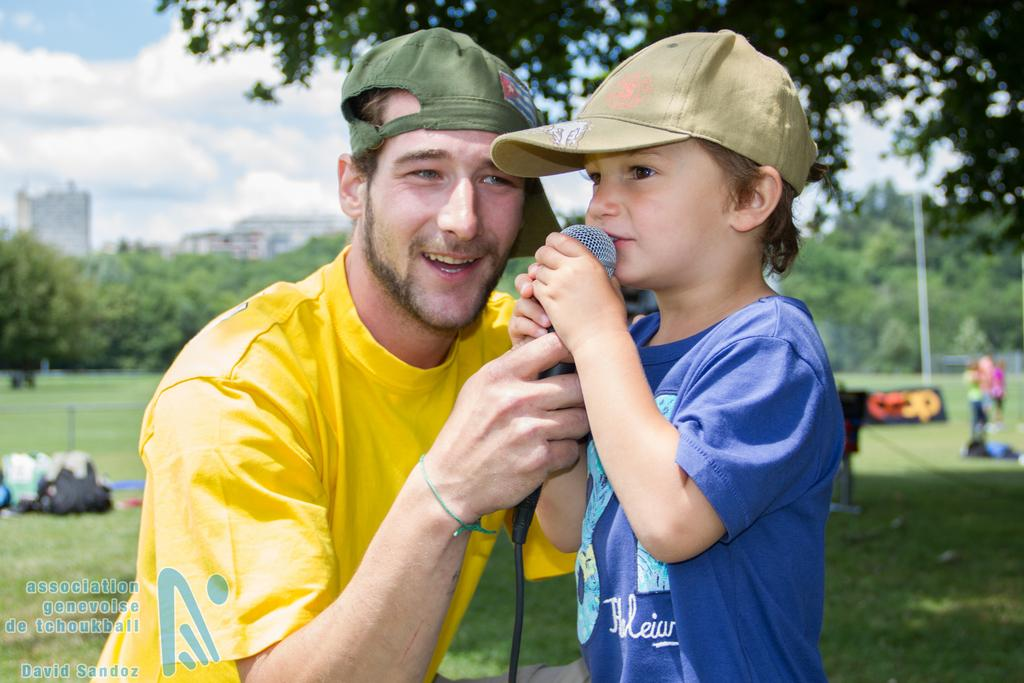What is the main subject of the image? There is a child in the image. Can you describe the man in the image? The man is wearing a cap and holding a microphone. What type of environment is visible in the image? There is green grass, trees, and buildings visible in the image. What can be seen in the sky? Clouds are visible in the sky. What type of locket is the child wearing in the image? There is no locket visible on the child in the image. How does the man express his feelings of hate towards the child in the image? There is no indication of hate or any negative emotions in the image; the man is holding a microphone, and the child appears to be present in a positive setting. 